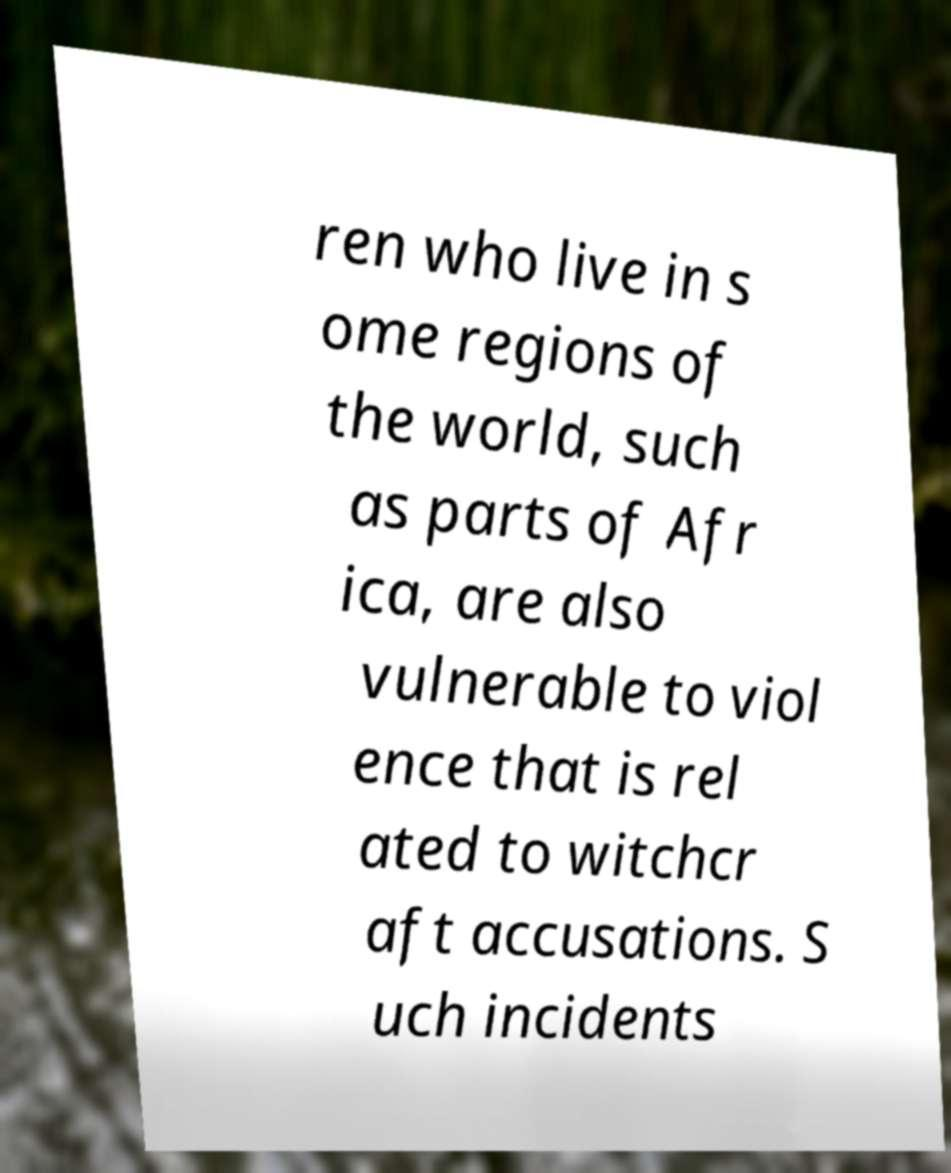Can you accurately transcribe the text from the provided image for me? ren who live in s ome regions of the world, such as parts of Afr ica, are also vulnerable to viol ence that is rel ated to witchcr aft accusations. S uch incidents 